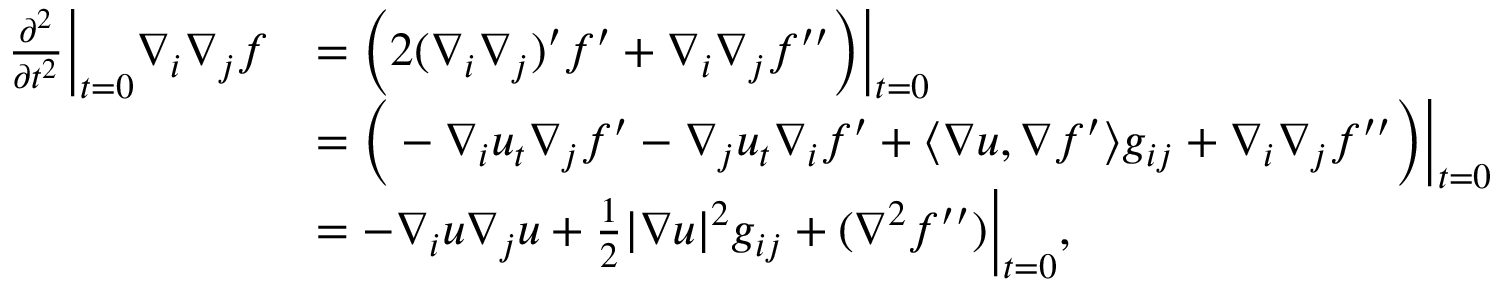Convert formula to latex. <formula><loc_0><loc_0><loc_500><loc_500>\begin{array} { r l } { \frac { \partial ^ { 2 } } { \partial t ^ { 2 } } \left | _ { t = 0 } \nabla _ { i } \nabla _ { j } f } & { = \left ( 2 ( \nabla _ { i } \nabla _ { j } ) ^ { \prime } f ^ { \prime } + \nabla _ { i } \nabla _ { j } f ^ { \prime \prime } \right ) \right | _ { t = 0 } } \\ & { = \left ( - \nabla _ { i } u _ { t } \nabla _ { j } f ^ { \prime } - \nabla _ { j } u _ { t } \nabla _ { i } f ^ { \prime } + \langle \nabla u , \nabla f ^ { \prime } \rangle g _ { i j } + \nabla _ { i } \nabla _ { j } f ^ { \prime \prime } \right ) \left | _ { t = 0 } } \\ & { = - \nabla _ { i } u \nabla _ { j } u + \frac { 1 } { 2 } | \nabla u | ^ { 2 } g _ { i j } + ( \nabla ^ { 2 } f ^ { \prime \prime } ) \right | _ { t = 0 } , } \end{array}</formula> 